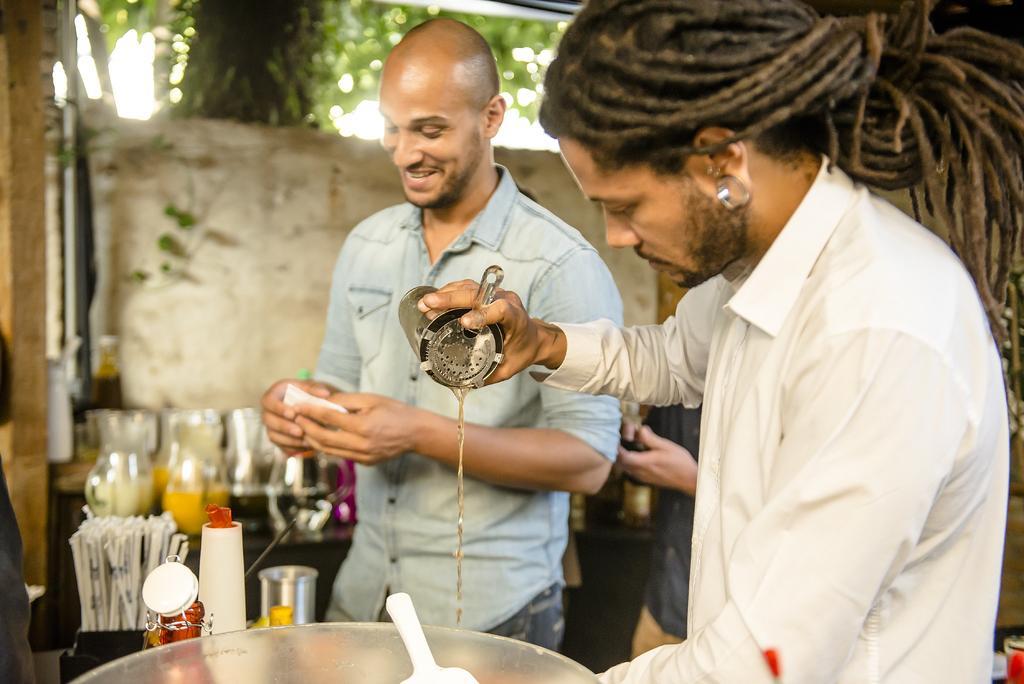Describe this image in one or two sentences. In this picture we can see few people, in front of them we can find few jugs, bottle and other things on the tables, in the background we can see a tree. 